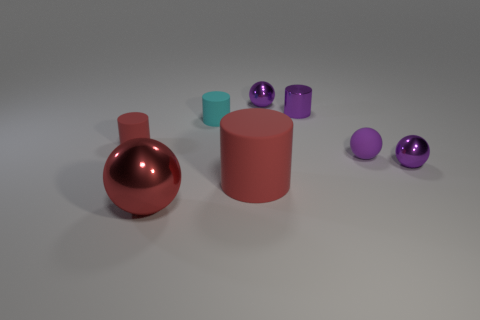Subtract all yellow cylinders. How many purple spheres are left? 3 Subtract 1 spheres. How many spheres are left? 3 Add 2 tiny yellow rubber objects. How many objects exist? 10 Add 5 gray matte cubes. How many gray matte cubes exist? 5 Subtract 0 cyan balls. How many objects are left? 8 Subtract all small shiny spheres. Subtract all cyan things. How many objects are left? 5 Add 4 tiny objects. How many tiny objects are left? 10 